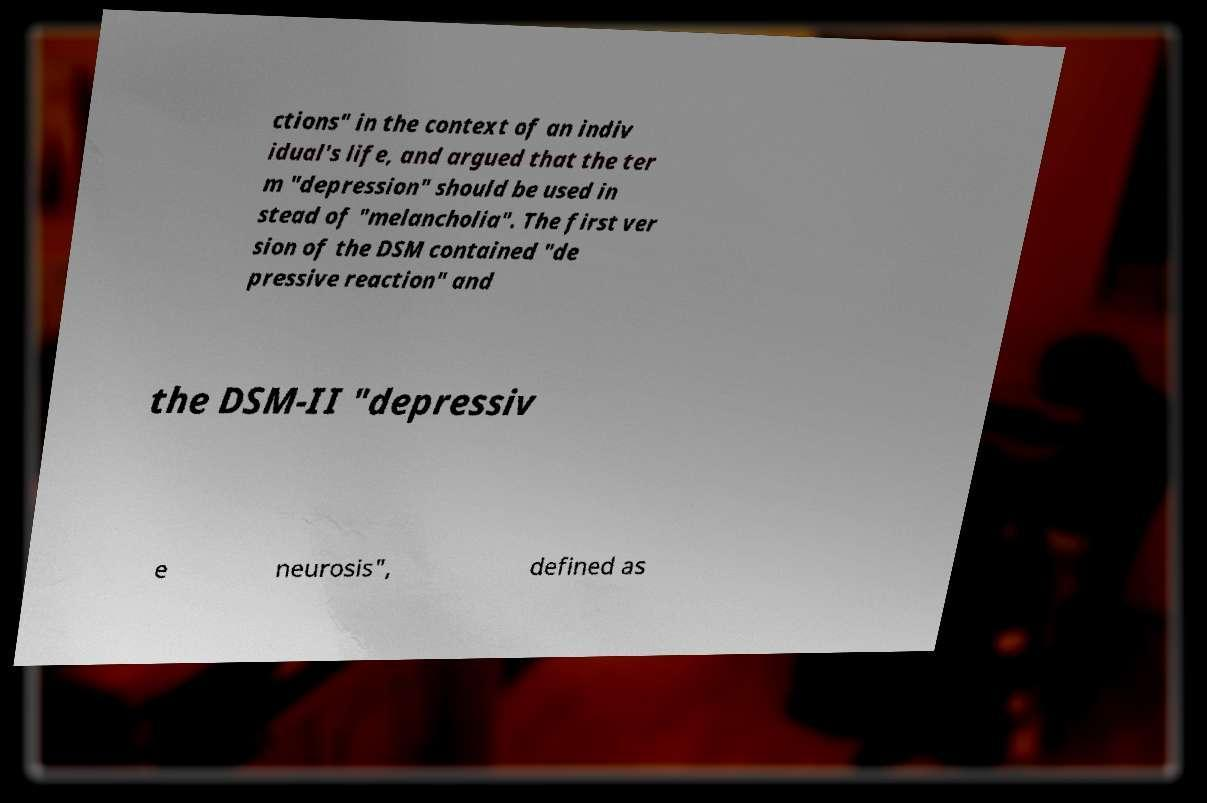Can you read and provide the text displayed in the image?This photo seems to have some interesting text. Can you extract and type it out for me? ctions" in the context of an indiv idual's life, and argued that the ter m "depression" should be used in stead of "melancholia". The first ver sion of the DSM contained "de pressive reaction" and the DSM-II "depressiv e neurosis", defined as 